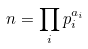<formula> <loc_0><loc_0><loc_500><loc_500>n = \prod _ { i } p _ { i } ^ { a _ { i } }</formula> 